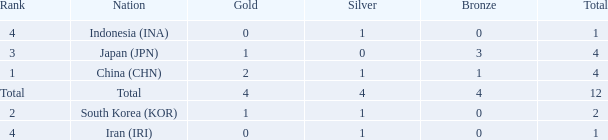What is the fewest gold medals for the nation with 4 silvers and more than 4 bronze? None. Parse the table in full. {'header': ['Rank', 'Nation', 'Gold', 'Silver', 'Bronze', 'Total'], 'rows': [['4', 'Indonesia (INA)', '0', '1', '0', '1'], ['3', 'Japan (JPN)', '1', '0', '3', '4'], ['1', 'China (CHN)', '2', '1', '1', '4'], ['Total', 'Total', '4', '4', '4', '12'], ['2', 'South Korea (KOR)', '1', '1', '0', '2'], ['4', 'Iran (IRI)', '0', '1', '0', '1']]} 